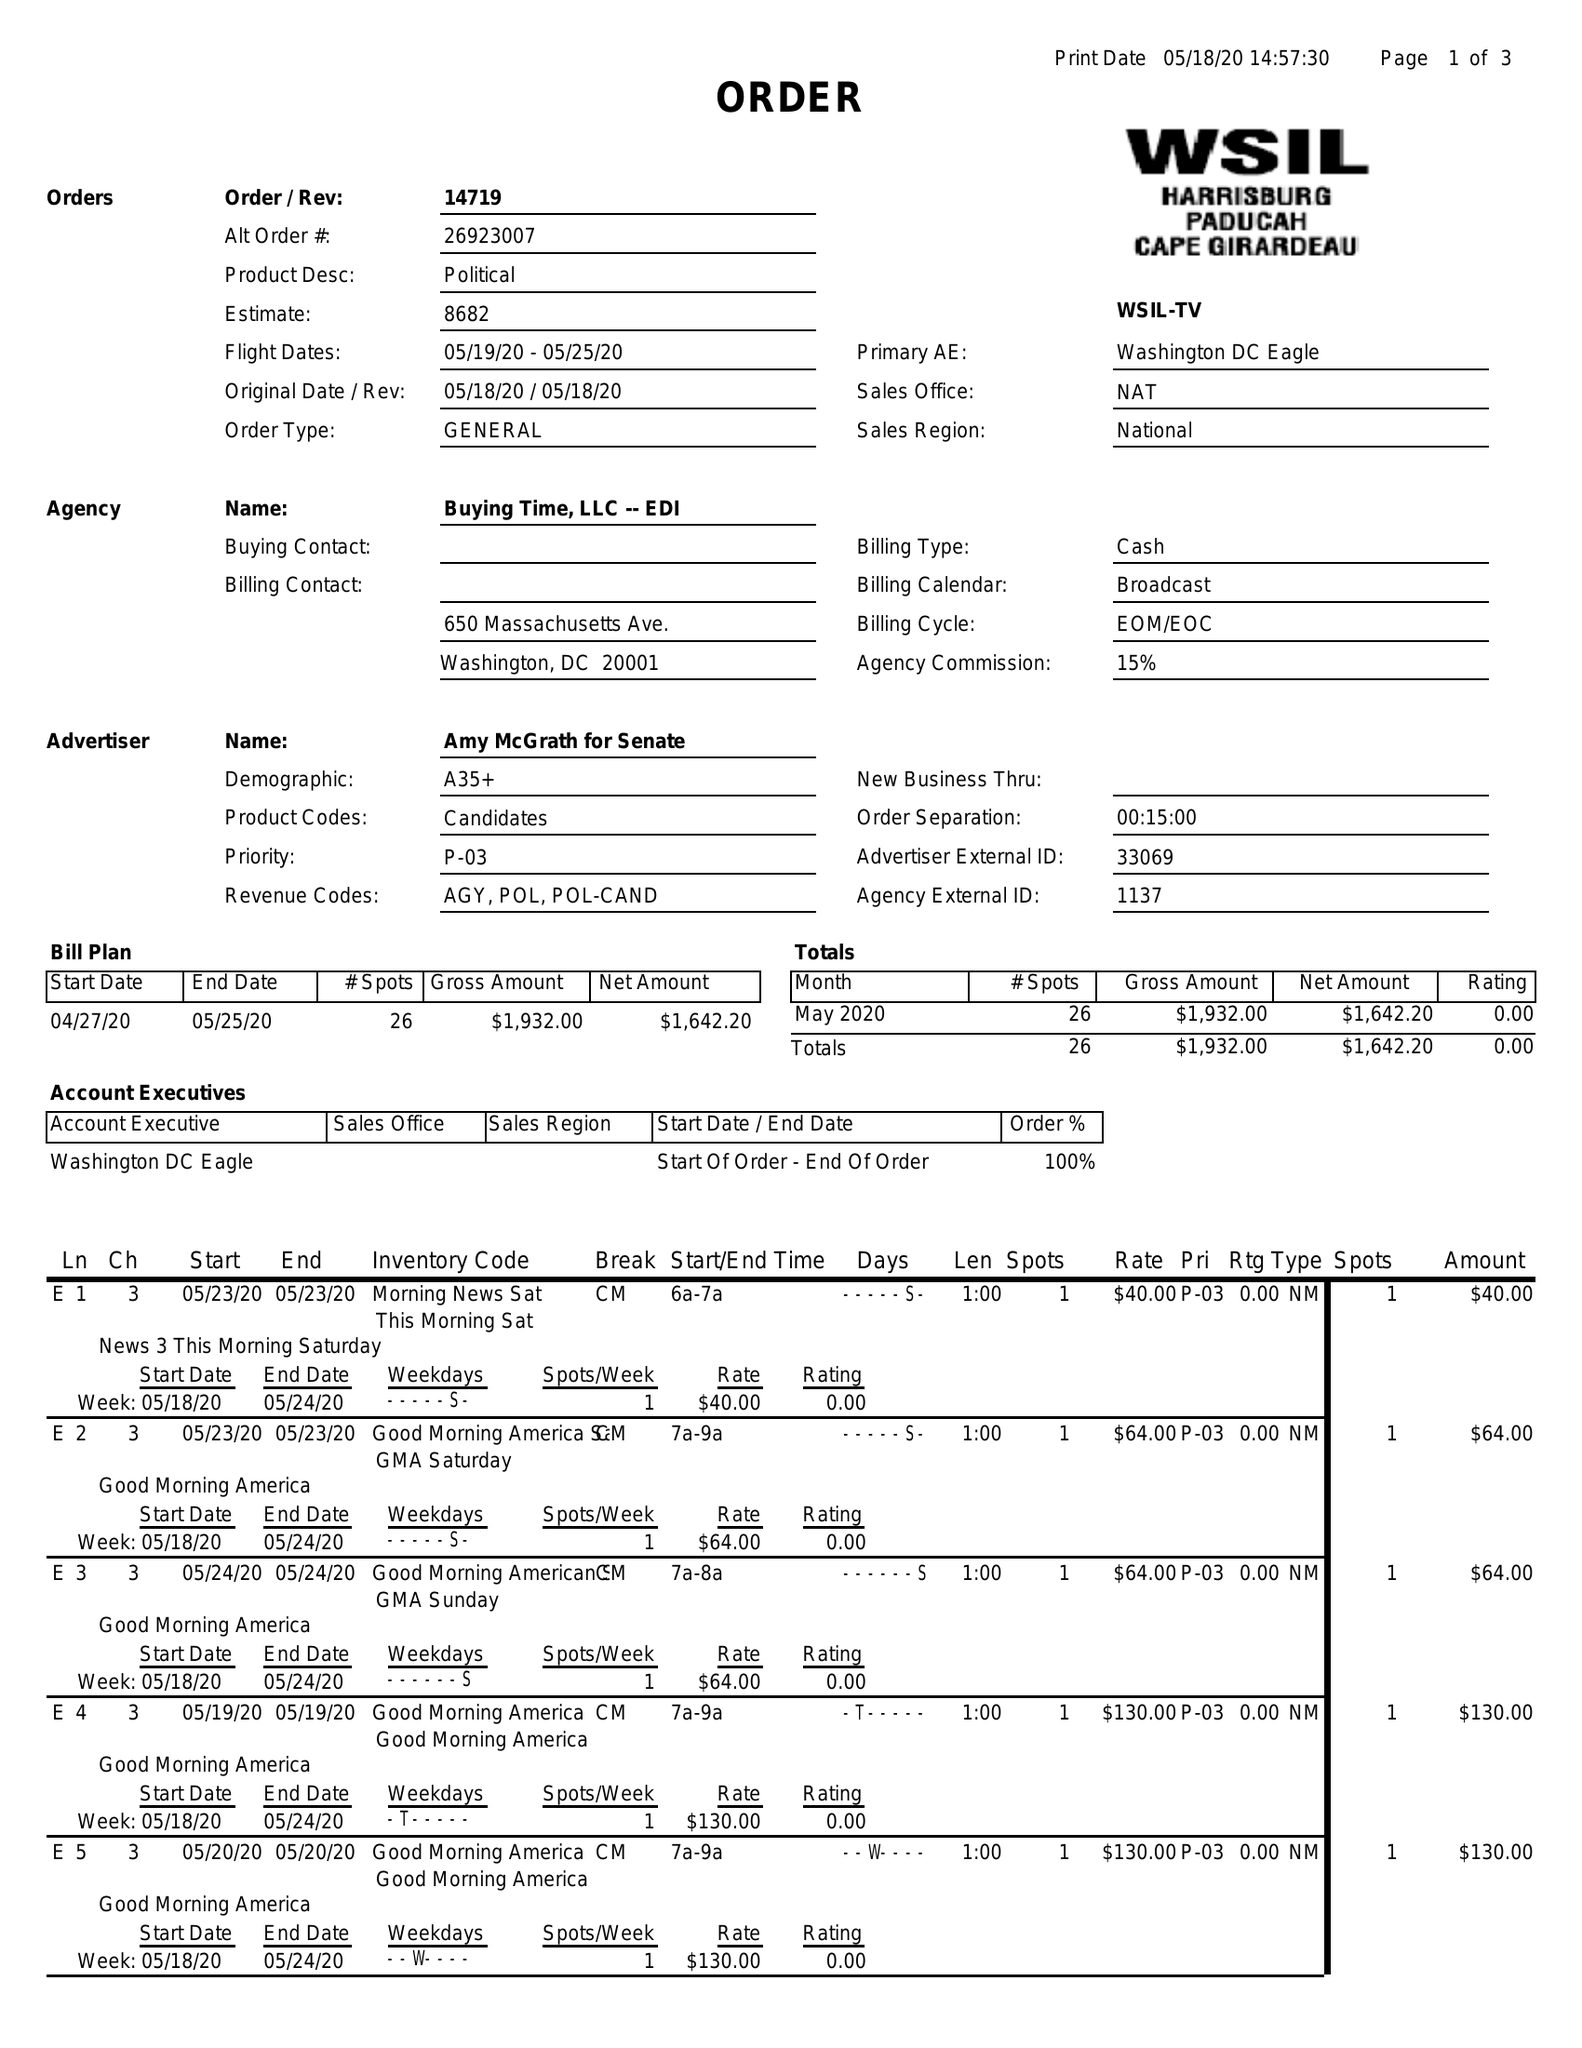What is the value for the gross_amount?
Answer the question using a single word or phrase. 1932.00 